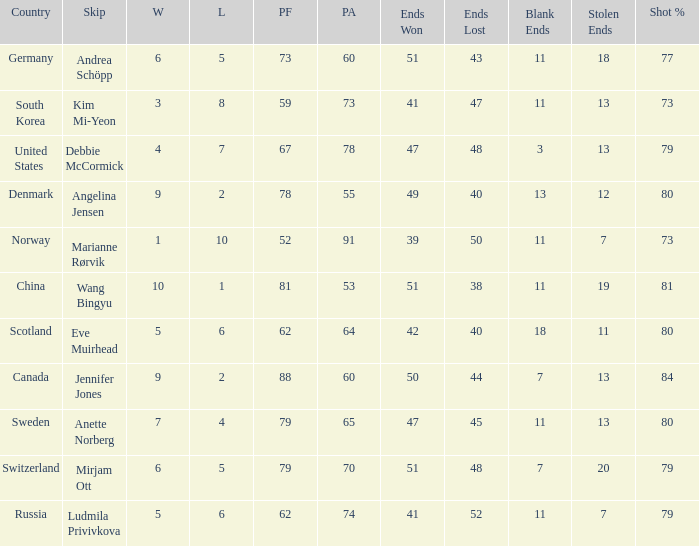What is the minimum Wins a team has? 1.0. 